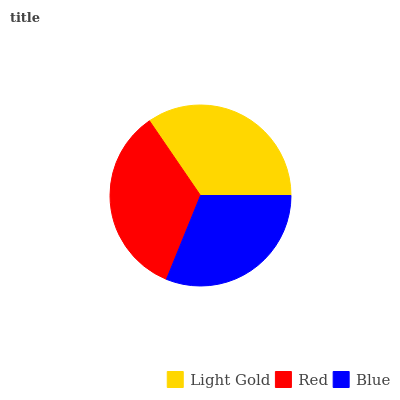Is Blue the minimum?
Answer yes or no. Yes. Is Light Gold the maximum?
Answer yes or no. Yes. Is Red the minimum?
Answer yes or no. No. Is Red the maximum?
Answer yes or no. No. Is Light Gold greater than Red?
Answer yes or no. Yes. Is Red less than Light Gold?
Answer yes or no. Yes. Is Red greater than Light Gold?
Answer yes or no. No. Is Light Gold less than Red?
Answer yes or no. No. Is Red the high median?
Answer yes or no. Yes. Is Red the low median?
Answer yes or no. Yes. Is Light Gold the high median?
Answer yes or no. No. Is Blue the low median?
Answer yes or no. No. 